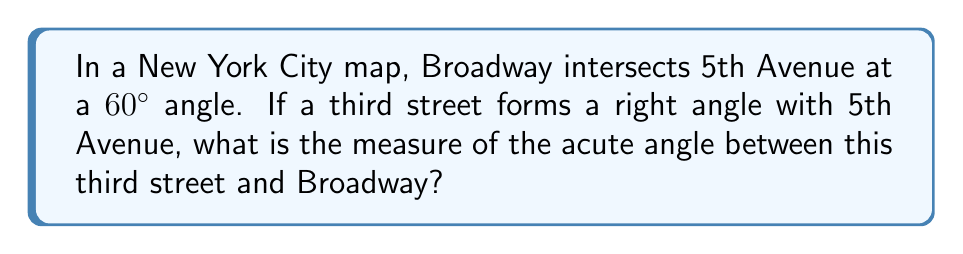Help me with this question. Let's approach this step-by-step:

1) First, let's visualize the problem:

   [asy]
   import geometry;
   
   size(200);
   
   pair A = (0,0);
   pair B = (100,0);
   pair C = (50,86.6);
   
   draw(A--B, arrow=Arrow(TeXHead));
   draw(A--C, arrow=Arrow(TeXHead));
   draw(A--(50,-86.6), arrow=Arrow(TeXHead));
   
   label("5th Ave", (50,-5), S);
   label("Broadway", (25,43.3), NW);
   label("3rd Street", (25,-43.3), SW);
   label("60°", (10,10), NE);
   label("90°", (10,-10), SE);
   label("x°", (40,10), SE);
   
   [/asy]

2) We know that:
   - Broadway intersects 5th Avenue at a 60° angle
   - The third street forms a right angle (90°) with 5th Avenue
   - We need to find the acute angle $x$ between the third street and Broadway

3) In a straight line, the sum of angles is 180°. So, if we consider the angle formed by Broadway and the third street, we can write:

   $$ 60° + 90° + x° = 180° $$

4) Simplifying:

   $$ 150° + x° = 180° $$

5) Subtracting 150° from both sides:

   $$ x° = 180° - 150° = 30° $$

Therefore, the acute angle between the third street and Broadway is 30°.
Answer: 30° 